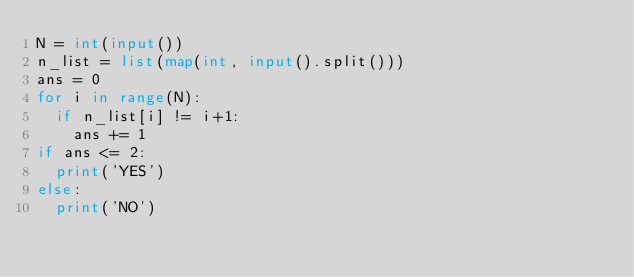<code> <loc_0><loc_0><loc_500><loc_500><_Python_>N = int(input())
n_list = list(map(int, input().split()))
ans = 0
for i in range(N):
  if n_list[i] != i+1:
    ans += 1
if ans <= 2:
  print('YES')
else:
  print('NO')</code> 